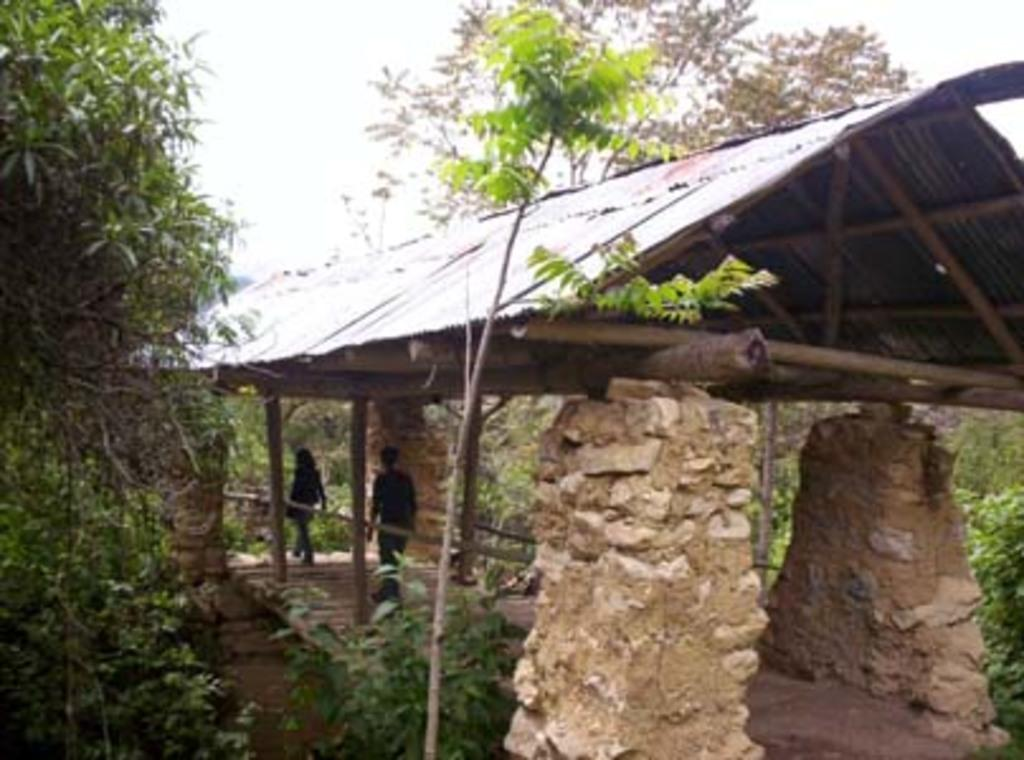What type of structure is present in the image? There is a shed with pillars in the image. What are the people in the image doing? Two people are walking in the image. What type of vegetation can be seen in the image? There are plants and trees in the image. What can be seen in the background of the image? The sky is visible in the background of the image. What type of marble is being used to decorate the shed in the image? There is no marble present in the image; the shed has pillars but no mention of marble. What type of oatmeal is being served to the people walking in the image? There is no oatmeal present in the image; the people are walking but no food is mentioned. 